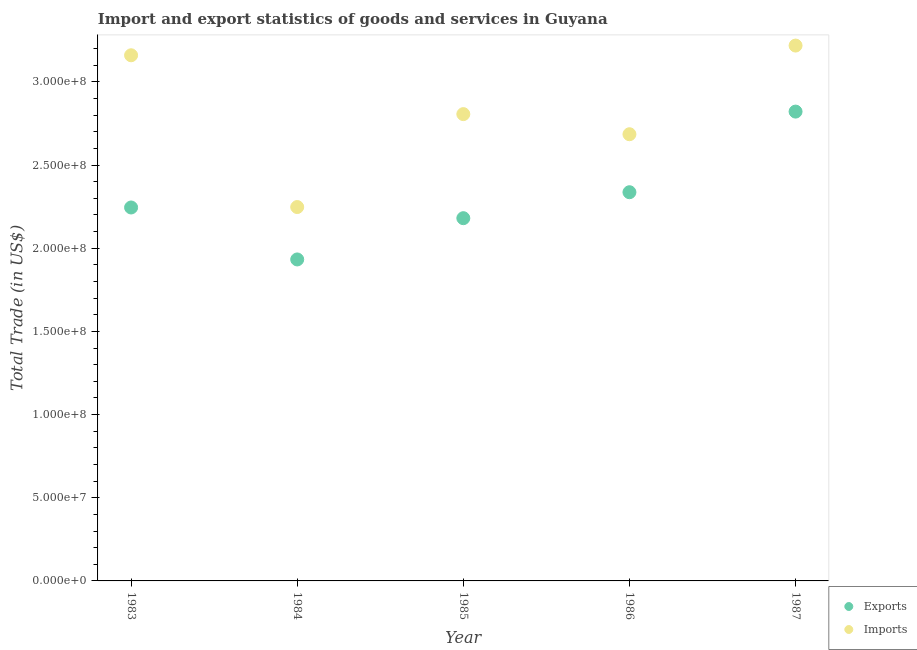How many different coloured dotlines are there?
Your answer should be very brief. 2. Is the number of dotlines equal to the number of legend labels?
Your response must be concise. Yes. What is the imports of goods and services in 1983?
Your answer should be compact. 3.16e+08. Across all years, what is the maximum export of goods and services?
Provide a short and direct response. 2.82e+08. Across all years, what is the minimum export of goods and services?
Keep it short and to the point. 1.93e+08. In which year was the export of goods and services maximum?
Your answer should be very brief. 1987. What is the total imports of goods and services in the graph?
Your answer should be very brief. 1.41e+09. What is the difference between the export of goods and services in 1983 and that in 1986?
Make the answer very short. -9.17e+06. What is the difference between the export of goods and services in 1987 and the imports of goods and services in 1983?
Provide a short and direct response. -3.39e+07. What is the average export of goods and services per year?
Offer a terse response. 2.30e+08. In the year 1987, what is the difference between the imports of goods and services and export of goods and services?
Provide a short and direct response. 3.97e+07. In how many years, is the export of goods and services greater than 280000000 US$?
Offer a terse response. 1. What is the ratio of the export of goods and services in 1984 to that in 1987?
Make the answer very short. 0.68. Is the export of goods and services in 1983 less than that in 1985?
Your answer should be compact. No. What is the difference between the highest and the second highest export of goods and services?
Your answer should be compact. 4.85e+07. What is the difference between the highest and the lowest imports of goods and services?
Offer a very short reply. 9.71e+07. Does the export of goods and services monotonically increase over the years?
Offer a very short reply. No. Is the export of goods and services strictly less than the imports of goods and services over the years?
Your response must be concise. Yes. Does the graph contain any zero values?
Provide a short and direct response. No. How many legend labels are there?
Offer a very short reply. 2. How are the legend labels stacked?
Your answer should be very brief. Vertical. What is the title of the graph?
Offer a very short reply. Import and export statistics of goods and services in Guyana. Does "Quasi money growth" appear as one of the legend labels in the graph?
Make the answer very short. No. What is the label or title of the Y-axis?
Provide a short and direct response. Total Trade (in US$). What is the Total Trade (in US$) of Exports in 1983?
Ensure brevity in your answer.  2.24e+08. What is the Total Trade (in US$) in Imports in 1983?
Provide a short and direct response. 3.16e+08. What is the Total Trade (in US$) of Exports in 1984?
Provide a short and direct response. 1.93e+08. What is the Total Trade (in US$) of Imports in 1984?
Keep it short and to the point. 2.25e+08. What is the Total Trade (in US$) in Exports in 1985?
Offer a very short reply. 2.18e+08. What is the Total Trade (in US$) of Imports in 1985?
Offer a very short reply. 2.81e+08. What is the Total Trade (in US$) of Exports in 1986?
Your answer should be very brief. 2.34e+08. What is the Total Trade (in US$) in Imports in 1986?
Offer a very short reply. 2.69e+08. What is the Total Trade (in US$) of Exports in 1987?
Provide a short and direct response. 2.82e+08. What is the Total Trade (in US$) of Imports in 1987?
Provide a short and direct response. 3.22e+08. Across all years, what is the maximum Total Trade (in US$) of Exports?
Ensure brevity in your answer.  2.82e+08. Across all years, what is the maximum Total Trade (in US$) in Imports?
Keep it short and to the point. 3.22e+08. Across all years, what is the minimum Total Trade (in US$) in Exports?
Give a very brief answer. 1.93e+08. Across all years, what is the minimum Total Trade (in US$) in Imports?
Keep it short and to the point. 2.25e+08. What is the total Total Trade (in US$) in Exports in the graph?
Offer a terse response. 1.15e+09. What is the total Total Trade (in US$) in Imports in the graph?
Your response must be concise. 1.41e+09. What is the difference between the Total Trade (in US$) in Exports in 1983 and that in 1984?
Your answer should be compact. 3.12e+07. What is the difference between the Total Trade (in US$) of Imports in 1983 and that in 1984?
Your answer should be very brief. 9.12e+07. What is the difference between the Total Trade (in US$) in Exports in 1983 and that in 1985?
Keep it short and to the point. 6.43e+06. What is the difference between the Total Trade (in US$) in Imports in 1983 and that in 1985?
Keep it short and to the point. 3.54e+07. What is the difference between the Total Trade (in US$) in Exports in 1983 and that in 1986?
Your answer should be very brief. -9.17e+06. What is the difference between the Total Trade (in US$) in Imports in 1983 and that in 1986?
Provide a succinct answer. 4.75e+07. What is the difference between the Total Trade (in US$) of Exports in 1983 and that in 1987?
Provide a short and direct response. -5.76e+07. What is the difference between the Total Trade (in US$) of Imports in 1983 and that in 1987?
Ensure brevity in your answer.  -5.84e+06. What is the difference between the Total Trade (in US$) of Exports in 1984 and that in 1985?
Give a very brief answer. -2.48e+07. What is the difference between the Total Trade (in US$) in Imports in 1984 and that in 1985?
Offer a very short reply. -5.59e+07. What is the difference between the Total Trade (in US$) in Exports in 1984 and that in 1986?
Your answer should be compact. -4.04e+07. What is the difference between the Total Trade (in US$) of Imports in 1984 and that in 1986?
Provide a succinct answer. -4.38e+07. What is the difference between the Total Trade (in US$) in Exports in 1984 and that in 1987?
Provide a succinct answer. -8.89e+07. What is the difference between the Total Trade (in US$) in Imports in 1984 and that in 1987?
Provide a succinct answer. -9.71e+07. What is the difference between the Total Trade (in US$) of Exports in 1985 and that in 1986?
Make the answer very short. -1.56e+07. What is the difference between the Total Trade (in US$) of Imports in 1985 and that in 1986?
Make the answer very short. 1.21e+07. What is the difference between the Total Trade (in US$) in Exports in 1985 and that in 1987?
Your response must be concise. -6.41e+07. What is the difference between the Total Trade (in US$) in Imports in 1985 and that in 1987?
Your answer should be very brief. -4.12e+07. What is the difference between the Total Trade (in US$) of Exports in 1986 and that in 1987?
Your answer should be very brief. -4.85e+07. What is the difference between the Total Trade (in US$) in Imports in 1986 and that in 1987?
Make the answer very short. -5.33e+07. What is the difference between the Total Trade (in US$) of Exports in 1983 and the Total Trade (in US$) of Imports in 1984?
Your response must be concise. -2.63e+05. What is the difference between the Total Trade (in US$) of Exports in 1983 and the Total Trade (in US$) of Imports in 1985?
Keep it short and to the point. -5.61e+07. What is the difference between the Total Trade (in US$) of Exports in 1983 and the Total Trade (in US$) of Imports in 1986?
Your answer should be compact. -4.40e+07. What is the difference between the Total Trade (in US$) of Exports in 1983 and the Total Trade (in US$) of Imports in 1987?
Your answer should be compact. -9.73e+07. What is the difference between the Total Trade (in US$) in Exports in 1984 and the Total Trade (in US$) in Imports in 1985?
Your answer should be compact. -8.74e+07. What is the difference between the Total Trade (in US$) of Exports in 1984 and the Total Trade (in US$) of Imports in 1986?
Give a very brief answer. -7.53e+07. What is the difference between the Total Trade (in US$) in Exports in 1984 and the Total Trade (in US$) in Imports in 1987?
Keep it short and to the point. -1.29e+08. What is the difference between the Total Trade (in US$) of Exports in 1985 and the Total Trade (in US$) of Imports in 1986?
Provide a succinct answer. -5.05e+07. What is the difference between the Total Trade (in US$) of Exports in 1985 and the Total Trade (in US$) of Imports in 1987?
Your answer should be very brief. -1.04e+08. What is the difference between the Total Trade (in US$) of Exports in 1986 and the Total Trade (in US$) of Imports in 1987?
Offer a terse response. -8.82e+07. What is the average Total Trade (in US$) of Exports per year?
Your answer should be compact. 2.30e+08. What is the average Total Trade (in US$) in Imports per year?
Ensure brevity in your answer.  2.82e+08. In the year 1983, what is the difference between the Total Trade (in US$) in Exports and Total Trade (in US$) in Imports?
Your response must be concise. -9.15e+07. In the year 1984, what is the difference between the Total Trade (in US$) of Exports and Total Trade (in US$) of Imports?
Ensure brevity in your answer.  -3.15e+07. In the year 1985, what is the difference between the Total Trade (in US$) of Exports and Total Trade (in US$) of Imports?
Ensure brevity in your answer.  -6.26e+07. In the year 1986, what is the difference between the Total Trade (in US$) of Exports and Total Trade (in US$) of Imports?
Your response must be concise. -3.49e+07. In the year 1987, what is the difference between the Total Trade (in US$) in Exports and Total Trade (in US$) in Imports?
Make the answer very short. -3.97e+07. What is the ratio of the Total Trade (in US$) in Exports in 1983 to that in 1984?
Offer a very short reply. 1.16. What is the ratio of the Total Trade (in US$) in Imports in 1983 to that in 1984?
Offer a very short reply. 1.41. What is the ratio of the Total Trade (in US$) in Exports in 1983 to that in 1985?
Offer a very short reply. 1.03. What is the ratio of the Total Trade (in US$) of Imports in 1983 to that in 1985?
Your answer should be very brief. 1.13. What is the ratio of the Total Trade (in US$) in Exports in 1983 to that in 1986?
Provide a short and direct response. 0.96. What is the ratio of the Total Trade (in US$) in Imports in 1983 to that in 1986?
Offer a very short reply. 1.18. What is the ratio of the Total Trade (in US$) of Exports in 1983 to that in 1987?
Offer a terse response. 0.8. What is the ratio of the Total Trade (in US$) of Imports in 1983 to that in 1987?
Make the answer very short. 0.98. What is the ratio of the Total Trade (in US$) of Exports in 1984 to that in 1985?
Offer a terse response. 0.89. What is the ratio of the Total Trade (in US$) of Imports in 1984 to that in 1985?
Make the answer very short. 0.8. What is the ratio of the Total Trade (in US$) of Exports in 1984 to that in 1986?
Ensure brevity in your answer.  0.83. What is the ratio of the Total Trade (in US$) of Imports in 1984 to that in 1986?
Give a very brief answer. 0.84. What is the ratio of the Total Trade (in US$) in Exports in 1984 to that in 1987?
Ensure brevity in your answer.  0.69. What is the ratio of the Total Trade (in US$) in Imports in 1984 to that in 1987?
Make the answer very short. 0.7. What is the ratio of the Total Trade (in US$) in Exports in 1985 to that in 1986?
Offer a terse response. 0.93. What is the ratio of the Total Trade (in US$) of Imports in 1985 to that in 1986?
Provide a short and direct response. 1.04. What is the ratio of the Total Trade (in US$) in Exports in 1985 to that in 1987?
Offer a terse response. 0.77. What is the ratio of the Total Trade (in US$) of Imports in 1985 to that in 1987?
Offer a terse response. 0.87. What is the ratio of the Total Trade (in US$) in Exports in 1986 to that in 1987?
Your response must be concise. 0.83. What is the ratio of the Total Trade (in US$) of Imports in 1986 to that in 1987?
Provide a succinct answer. 0.83. What is the difference between the highest and the second highest Total Trade (in US$) in Exports?
Your answer should be compact. 4.85e+07. What is the difference between the highest and the second highest Total Trade (in US$) of Imports?
Your response must be concise. 5.84e+06. What is the difference between the highest and the lowest Total Trade (in US$) of Exports?
Provide a succinct answer. 8.89e+07. What is the difference between the highest and the lowest Total Trade (in US$) of Imports?
Your response must be concise. 9.71e+07. 